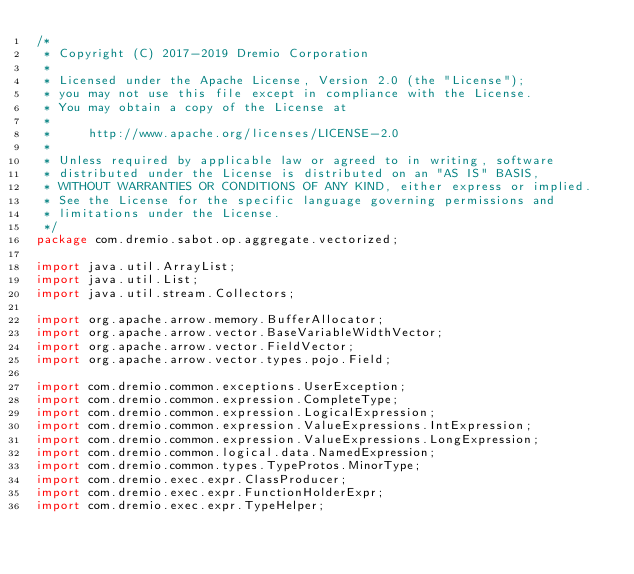Convert code to text. <code><loc_0><loc_0><loc_500><loc_500><_Java_>/*
 * Copyright (C) 2017-2019 Dremio Corporation
 *
 * Licensed under the Apache License, Version 2.0 (the "License");
 * you may not use this file except in compliance with the License.
 * You may obtain a copy of the License at
 *
 *     http://www.apache.org/licenses/LICENSE-2.0
 *
 * Unless required by applicable law or agreed to in writing, software
 * distributed under the License is distributed on an "AS IS" BASIS,
 * WITHOUT WARRANTIES OR CONDITIONS OF ANY KIND, either express or implied.
 * See the License for the specific language governing permissions and
 * limitations under the License.
 */
package com.dremio.sabot.op.aggregate.vectorized;

import java.util.ArrayList;
import java.util.List;
import java.util.stream.Collectors;

import org.apache.arrow.memory.BufferAllocator;
import org.apache.arrow.vector.BaseVariableWidthVector;
import org.apache.arrow.vector.FieldVector;
import org.apache.arrow.vector.types.pojo.Field;

import com.dremio.common.exceptions.UserException;
import com.dremio.common.expression.CompleteType;
import com.dremio.common.expression.LogicalExpression;
import com.dremio.common.expression.ValueExpressions.IntExpression;
import com.dremio.common.expression.ValueExpressions.LongExpression;
import com.dremio.common.logical.data.NamedExpression;
import com.dremio.common.types.TypeProtos.MinorType;
import com.dremio.exec.expr.ClassProducer;
import com.dremio.exec.expr.FunctionHolderExpr;
import com.dremio.exec.expr.TypeHelper;</code> 